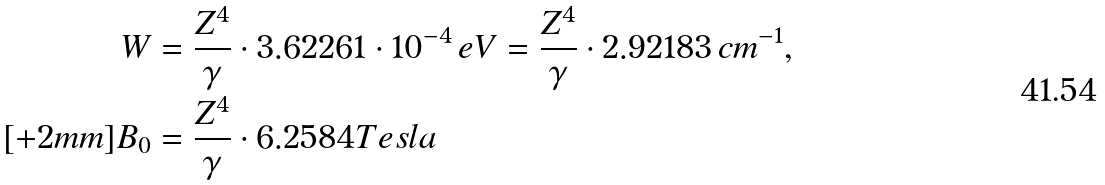Convert formula to latex. <formula><loc_0><loc_0><loc_500><loc_500>W & = \frac { Z ^ { 4 } } { \gamma } \cdot 3 . 6 2 2 6 1 \cdot 1 0 ^ { - 4 } \, e V = \frac { Z ^ { 4 } } { \gamma } \cdot 2 . 9 2 1 8 3 \, c m ^ { - 1 } , \\ [ + 2 m m ] B _ { 0 } & = \frac { Z ^ { 4 } } { \gamma } \cdot 6 . 2 5 8 4 T e s l a</formula> 